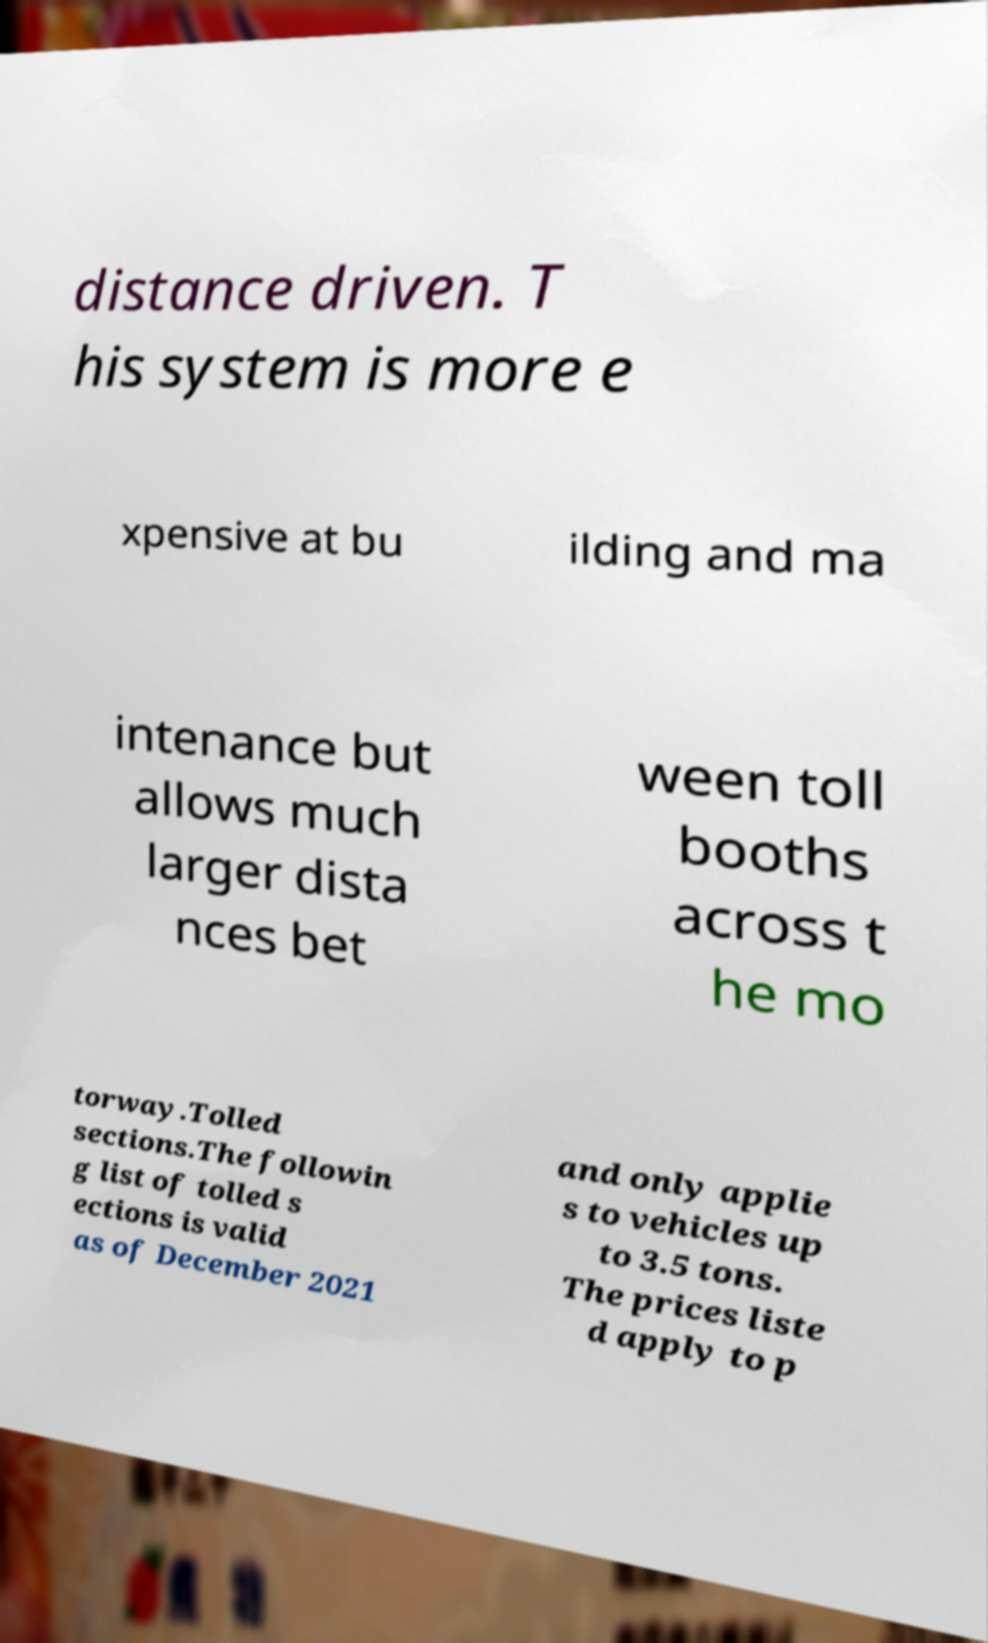There's text embedded in this image that I need extracted. Can you transcribe it verbatim? distance driven. T his system is more e xpensive at bu ilding and ma intenance but allows much larger dista nces bet ween toll booths across t he mo torway.Tolled sections.The followin g list of tolled s ections is valid as of December 2021 and only applie s to vehicles up to 3.5 tons. The prices liste d apply to p 